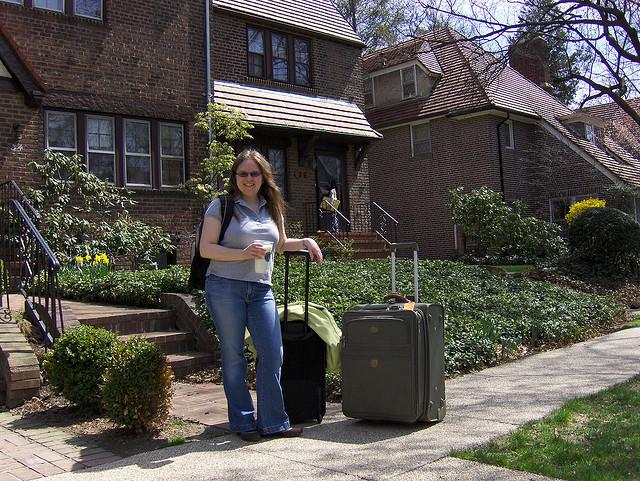What food and beverage purveyor did this woman visit most recently? starbucks 